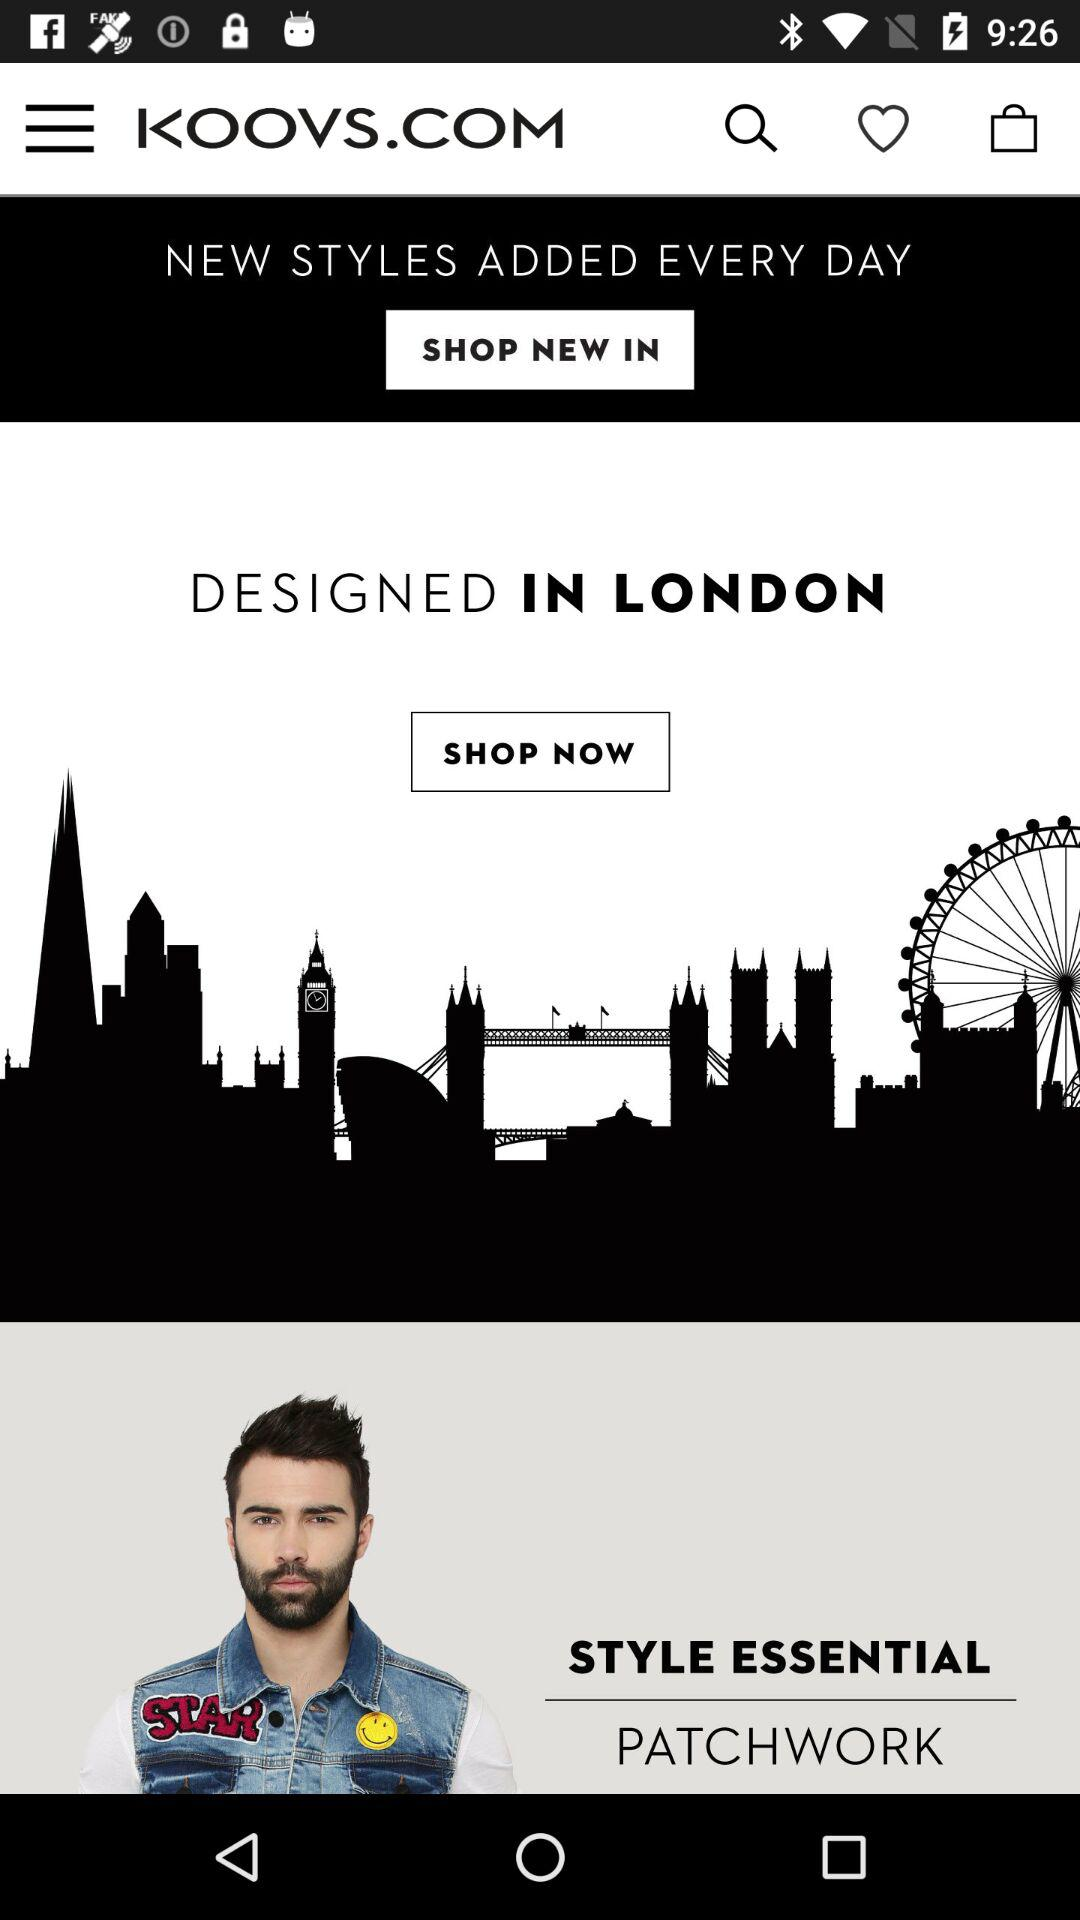What is the application name? The application name is "KOOVS". 